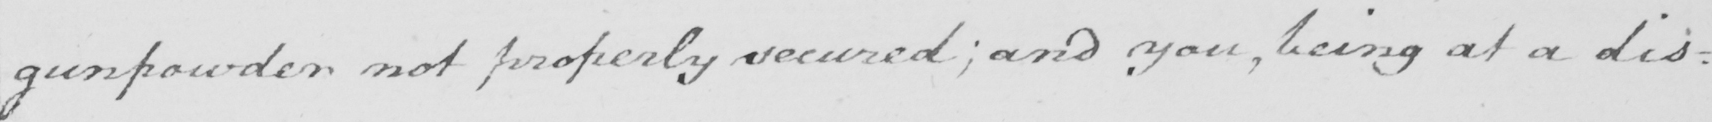What is written in this line of handwriting? gunpowder not properly secured  ; and you , being at a dis : 